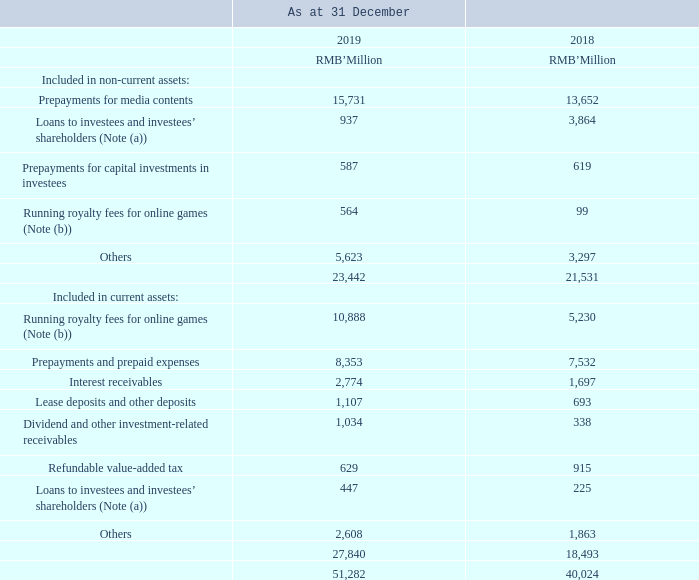PREPAYMENTS, DEPOSITS AND OTHER ASSETS
Note: (a) As at 31 December 2019, the balances of loans to investees and investees’ shareholders are mainly repayable within a period of one to five years (included in non-current assets), or within one year (included in current assets), and are interest-bearing at rates of not higher than 12.0% per annum (31 December 2018: not higher than 12.0% per annum).
(b) Running royalty fees for online games comprised prepaid royalty fees, unamortised running royalty fees and deferred Online Service Fees.
As at 31 December 2019, the carrying amounts of deposits and other assets (excludes prepayments and refundable value-added tax) approximated their fair values. Deposits and other assets were neither past due nor impaired.
What did the running royalty fees for online games comprise of? Prepaid royalty fees, unamortised running royalty fees and deferred online service fees. How much was the prepayment for media contents as at 31 December 2018?
Answer scale should be: million. 13,652. How much was the prepayment for media contents as at 31 December 2019?
Answer scale should be: million. 15,731. How much did the prepayments for media contents change by between 2018 year end and 2019 year end?
Answer scale should be: million. 15,731-13,652
Answer: 2079. How much did the prepayments and prepaid expenses change by between 2018 year end and 2019 year end?
Answer scale should be: million. 8,353-7,532
Answer: 821. How much did the interest receivables between 2018 year end and 2019 year end change by?
Answer scale should be: million. 2,774-1,697
Answer: 1077. 